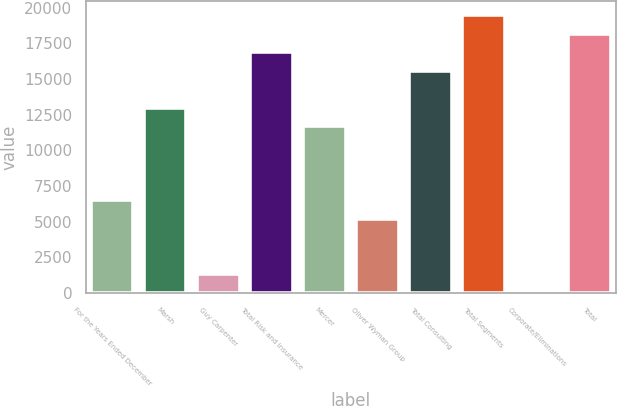Convert chart. <chart><loc_0><loc_0><loc_500><loc_500><bar_chart><fcel>For the Years Ended December<fcel>Marsh<fcel>Guy Carpenter<fcel>Total Risk and Insurance<fcel>Mercer<fcel>Oliver Wyman Group<fcel>Total Consulting<fcel>Total Segments<fcel>Corporate/Eliminations<fcel>Total<nl><fcel>6514.5<fcel>12990<fcel>1334.1<fcel>16875.3<fcel>11694.9<fcel>5219.4<fcel>15580.2<fcel>19465.5<fcel>39<fcel>18170.4<nl></chart> 